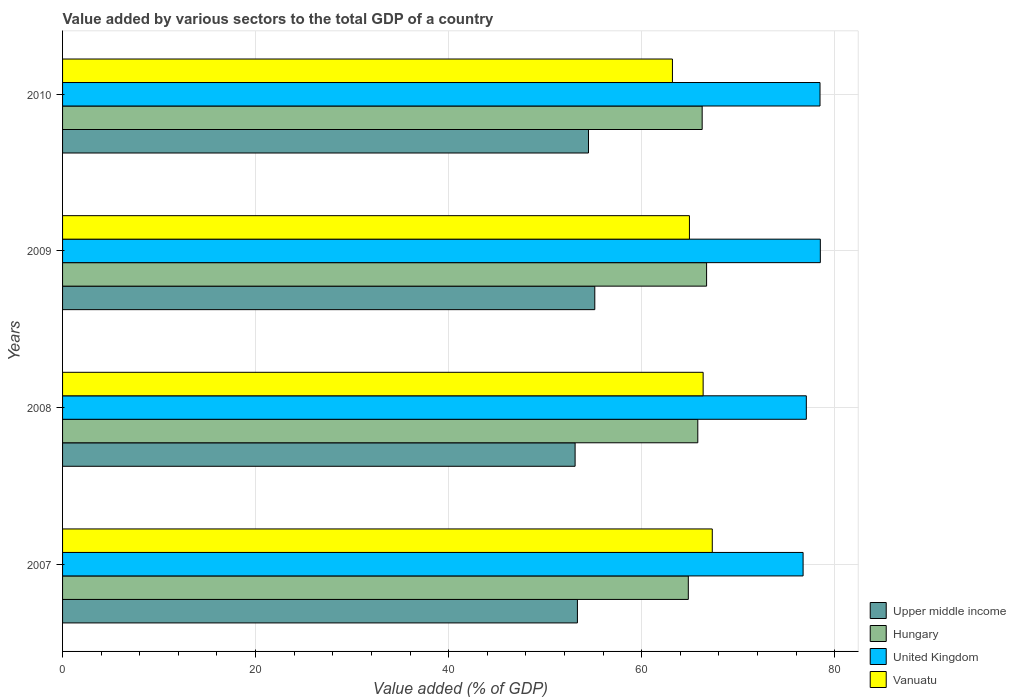How many bars are there on the 2nd tick from the top?
Your answer should be compact. 4. What is the label of the 3rd group of bars from the top?
Your answer should be compact. 2008. What is the value added by various sectors to the total GDP in Hungary in 2009?
Keep it short and to the point. 66.73. Across all years, what is the maximum value added by various sectors to the total GDP in Upper middle income?
Ensure brevity in your answer.  55.15. Across all years, what is the minimum value added by various sectors to the total GDP in United Kingdom?
Your response must be concise. 76.73. In which year was the value added by various sectors to the total GDP in United Kingdom maximum?
Make the answer very short. 2009. In which year was the value added by various sectors to the total GDP in Vanuatu minimum?
Offer a terse response. 2010. What is the total value added by various sectors to the total GDP in United Kingdom in the graph?
Offer a terse response. 310.8. What is the difference between the value added by various sectors to the total GDP in Vanuatu in 2008 and that in 2010?
Provide a succinct answer. 3.18. What is the difference between the value added by various sectors to the total GDP in Vanuatu in 2010 and the value added by various sectors to the total GDP in United Kingdom in 2008?
Your answer should be compact. -13.87. What is the average value added by various sectors to the total GDP in Vanuatu per year?
Offer a terse response. 65.46. In the year 2008, what is the difference between the value added by various sectors to the total GDP in Upper middle income and value added by various sectors to the total GDP in Hungary?
Give a very brief answer. -12.71. In how many years, is the value added by various sectors to the total GDP in Vanuatu greater than 40 %?
Give a very brief answer. 4. What is the ratio of the value added by various sectors to the total GDP in Hungary in 2008 to that in 2009?
Give a very brief answer. 0.99. Is the difference between the value added by various sectors to the total GDP in Upper middle income in 2009 and 2010 greater than the difference between the value added by various sectors to the total GDP in Hungary in 2009 and 2010?
Your response must be concise. Yes. What is the difference between the highest and the second highest value added by various sectors to the total GDP in Hungary?
Provide a short and direct response. 0.46. What is the difference between the highest and the lowest value added by various sectors to the total GDP in Upper middle income?
Make the answer very short. 2.04. What does the 2nd bar from the top in 2007 represents?
Offer a terse response. United Kingdom. What does the 2nd bar from the bottom in 2009 represents?
Offer a terse response. Hungary. How many bars are there?
Provide a succinct answer. 16. Are all the bars in the graph horizontal?
Your response must be concise. Yes. Are the values on the major ticks of X-axis written in scientific E-notation?
Keep it short and to the point. No. Does the graph contain grids?
Your response must be concise. Yes. What is the title of the graph?
Give a very brief answer. Value added by various sectors to the total GDP of a country. Does "Isle of Man" appear as one of the legend labels in the graph?
Give a very brief answer. No. What is the label or title of the X-axis?
Keep it short and to the point. Value added (% of GDP). What is the Value added (% of GDP) of Upper middle income in 2007?
Make the answer very short. 53.35. What is the Value added (% of GDP) in Hungary in 2007?
Ensure brevity in your answer.  64.84. What is the Value added (% of GDP) in United Kingdom in 2007?
Your answer should be very brief. 76.73. What is the Value added (% of GDP) in Vanuatu in 2007?
Give a very brief answer. 67.32. What is the Value added (% of GDP) of Upper middle income in 2008?
Your answer should be very brief. 53.11. What is the Value added (% of GDP) of Hungary in 2008?
Your answer should be very brief. 65.82. What is the Value added (% of GDP) of United Kingdom in 2008?
Your answer should be very brief. 77.07. What is the Value added (% of GDP) of Vanuatu in 2008?
Offer a very short reply. 66.37. What is the Value added (% of GDP) in Upper middle income in 2009?
Your answer should be very brief. 55.15. What is the Value added (% of GDP) in Hungary in 2009?
Offer a terse response. 66.73. What is the Value added (% of GDP) of United Kingdom in 2009?
Give a very brief answer. 78.52. What is the Value added (% of GDP) in Vanuatu in 2009?
Ensure brevity in your answer.  64.95. What is the Value added (% of GDP) in Upper middle income in 2010?
Make the answer very short. 54.49. What is the Value added (% of GDP) of Hungary in 2010?
Your answer should be compact. 66.27. What is the Value added (% of GDP) of United Kingdom in 2010?
Make the answer very short. 78.48. What is the Value added (% of GDP) in Vanuatu in 2010?
Your response must be concise. 63.19. Across all years, what is the maximum Value added (% of GDP) in Upper middle income?
Keep it short and to the point. 55.15. Across all years, what is the maximum Value added (% of GDP) of Hungary?
Offer a terse response. 66.73. Across all years, what is the maximum Value added (% of GDP) of United Kingdom?
Provide a short and direct response. 78.52. Across all years, what is the maximum Value added (% of GDP) in Vanuatu?
Your answer should be very brief. 67.32. Across all years, what is the minimum Value added (% of GDP) of Upper middle income?
Offer a terse response. 53.11. Across all years, what is the minimum Value added (% of GDP) of Hungary?
Your answer should be compact. 64.84. Across all years, what is the minimum Value added (% of GDP) in United Kingdom?
Ensure brevity in your answer.  76.73. Across all years, what is the minimum Value added (% of GDP) of Vanuatu?
Ensure brevity in your answer.  63.19. What is the total Value added (% of GDP) in Upper middle income in the graph?
Offer a terse response. 216.1. What is the total Value added (% of GDP) in Hungary in the graph?
Provide a succinct answer. 263.67. What is the total Value added (% of GDP) in United Kingdom in the graph?
Your answer should be very brief. 310.8. What is the total Value added (% of GDP) in Vanuatu in the graph?
Offer a very short reply. 261.84. What is the difference between the Value added (% of GDP) in Upper middle income in 2007 and that in 2008?
Keep it short and to the point. 0.24. What is the difference between the Value added (% of GDP) of Hungary in 2007 and that in 2008?
Your answer should be very brief. -0.98. What is the difference between the Value added (% of GDP) in United Kingdom in 2007 and that in 2008?
Offer a terse response. -0.33. What is the difference between the Value added (% of GDP) in Vanuatu in 2007 and that in 2008?
Give a very brief answer. 0.95. What is the difference between the Value added (% of GDP) in Upper middle income in 2007 and that in 2009?
Your answer should be very brief. -1.8. What is the difference between the Value added (% of GDP) in Hungary in 2007 and that in 2009?
Provide a succinct answer. -1.89. What is the difference between the Value added (% of GDP) in United Kingdom in 2007 and that in 2009?
Offer a very short reply. -1.78. What is the difference between the Value added (% of GDP) of Vanuatu in 2007 and that in 2009?
Make the answer very short. 2.37. What is the difference between the Value added (% of GDP) of Upper middle income in 2007 and that in 2010?
Provide a succinct answer. -1.15. What is the difference between the Value added (% of GDP) in Hungary in 2007 and that in 2010?
Your answer should be very brief. -1.43. What is the difference between the Value added (% of GDP) in United Kingdom in 2007 and that in 2010?
Your answer should be very brief. -1.75. What is the difference between the Value added (% of GDP) in Vanuatu in 2007 and that in 2010?
Your answer should be very brief. 4.13. What is the difference between the Value added (% of GDP) of Upper middle income in 2008 and that in 2009?
Offer a terse response. -2.04. What is the difference between the Value added (% of GDP) in Hungary in 2008 and that in 2009?
Make the answer very short. -0.91. What is the difference between the Value added (% of GDP) of United Kingdom in 2008 and that in 2009?
Offer a terse response. -1.45. What is the difference between the Value added (% of GDP) in Vanuatu in 2008 and that in 2009?
Make the answer very short. 1.42. What is the difference between the Value added (% of GDP) of Upper middle income in 2008 and that in 2010?
Keep it short and to the point. -1.39. What is the difference between the Value added (% of GDP) of Hungary in 2008 and that in 2010?
Keep it short and to the point. -0.45. What is the difference between the Value added (% of GDP) of United Kingdom in 2008 and that in 2010?
Make the answer very short. -1.42. What is the difference between the Value added (% of GDP) in Vanuatu in 2008 and that in 2010?
Provide a succinct answer. 3.18. What is the difference between the Value added (% of GDP) in Upper middle income in 2009 and that in 2010?
Give a very brief answer. 0.65. What is the difference between the Value added (% of GDP) in Hungary in 2009 and that in 2010?
Provide a short and direct response. 0.46. What is the difference between the Value added (% of GDP) in United Kingdom in 2009 and that in 2010?
Give a very brief answer. 0.03. What is the difference between the Value added (% of GDP) in Vanuatu in 2009 and that in 2010?
Ensure brevity in your answer.  1.76. What is the difference between the Value added (% of GDP) in Upper middle income in 2007 and the Value added (% of GDP) in Hungary in 2008?
Provide a succinct answer. -12.47. What is the difference between the Value added (% of GDP) in Upper middle income in 2007 and the Value added (% of GDP) in United Kingdom in 2008?
Your answer should be very brief. -23.72. What is the difference between the Value added (% of GDP) in Upper middle income in 2007 and the Value added (% of GDP) in Vanuatu in 2008?
Your answer should be very brief. -13.03. What is the difference between the Value added (% of GDP) of Hungary in 2007 and the Value added (% of GDP) of United Kingdom in 2008?
Make the answer very short. -12.23. What is the difference between the Value added (% of GDP) of Hungary in 2007 and the Value added (% of GDP) of Vanuatu in 2008?
Your answer should be compact. -1.54. What is the difference between the Value added (% of GDP) of United Kingdom in 2007 and the Value added (% of GDP) of Vanuatu in 2008?
Keep it short and to the point. 10.36. What is the difference between the Value added (% of GDP) in Upper middle income in 2007 and the Value added (% of GDP) in Hungary in 2009?
Give a very brief answer. -13.38. What is the difference between the Value added (% of GDP) in Upper middle income in 2007 and the Value added (% of GDP) in United Kingdom in 2009?
Provide a succinct answer. -25.17. What is the difference between the Value added (% of GDP) of Upper middle income in 2007 and the Value added (% of GDP) of Vanuatu in 2009?
Give a very brief answer. -11.61. What is the difference between the Value added (% of GDP) in Hungary in 2007 and the Value added (% of GDP) in United Kingdom in 2009?
Give a very brief answer. -13.68. What is the difference between the Value added (% of GDP) of Hungary in 2007 and the Value added (% of GDP) of Vanuatu in 2009?
Provide a succinct answer. -0.12. What is the difference between the Value added (% of GDP) of United Kingdom in 2007 and the Value added (% of GDP) of Vanuatu in 2009?
Your answer should be compact. 11.78. What is the difference between the Value added (% of GDP) of Upper middle income in 2007 and the Value added (% of GDP) of Hungary in 2010?
Provide a short and direct response. -12.93. What is the difference between the Value added (% of GDP) in Upper middle income in 2007 and the Value added (% of GDP) in United Kingdom in 2010?
Make the answer very short. -25.14. What is the difference between the Value added (% of GDP) in Upper middle income in 2007 and the Value added (% of GDP) in Vanuatu in 2010?
Offer a terse response. -9.85. What is the difference between the Value added (% of GDP) of Hungary in 2007 and the Value added (% of GDP) of United Kingdom in 2010?
Offer a terse response. -13.65. What is the difference between the Value added (% of GDP) of Hungary in 2007 and the Value added (% of GDP) of Vanuatu in 2010?
Ensure brevity in your answer.  1.65. What is the difference between the Value added (% of GDP) of United Kingdom in 2007 and the Value added (% of GDP) of Vanuatu in 2010?
Your answer should be compact. 13.54. What is the difference between the Value added (% of GDP) in Upper middle income in 2008 and the Value added (% of GDP) in Hungary in 2009?
Offer a terse response. -13.62. What is the difference between the Value added (% of GDP) in Upper middle income in 2008 and the Value added (% of GDP) in United Kingdom in 2009?
Your answer should be compact. -25.41. What is the difference between the Value added (% of GDP) of Upper middle income in 2008 and the Value added (% of GDP) of Vanuatu in 2009?
Keep it short and to the point. -11.85. What is the difference between the Value added (% of GDP) of Hungary in 2008 and the Value added (% of GDP) of United Kingdom in 2009?
Offer a terse response. -12.7. What is the difference between the Value added (% of GDP) in Hungary in 2008 and the Value added (% of GDP) in Vanuatu in 2009?
Make the answer very short. 0.87. What is the difference between the Value added (% of GDP) of United Kingdom in 2008 and the Value added (% of GDP) of Vanuatu in 2009?
Make the answer very short. 12.11. What is the difference between the Value added (% of GDP) of Upper middle income in 2008 and the Value added (% of GDP) of Hungary in 2010?
Your answer should be very brief. -13.17. What is the difference between the Value added (% of GDP) in Upper middle income in 2008 and the Value added (% of GDP) in United Kingdom in 2010?
Your response must be concise. -25.38. What is the difference between the Value added (% of GDP) in Upper middle income in 2008 and the Value added (% of GDP) in Vanuatu in 2010?
Give a very brief answer. -10.09. What is the difference between the Value added (% of GDP) in Hungary in 2008 and the Value added (% of GDP) in United Kingdom in 2010?
Offer a terse response. -12.66. What is the difference between the Value added (% of GDP) of Hungary in 2008 and the Value added (% of GDP) of Vanuatu in 2010?
Give a very brief answer. 2.63. What is the difference between the Value added (% of GDP) of United Kingdom in 2008 and the Value added (% of GDP) of Vanuatu in 2010?
Ensure brevity in your answer.  13.87. What is the difference between the Value added (% of GDP) of Upper middle income in 2009 and the Value added (% of GDP) of Hungary in 2010?
Give a very brief answer. -11.13. What is the difference between the Value added (% of GDP) in Upper middle income in 2009 and the Value added (% of GDP) in United Kingdom in 2010?
Your answer should be compact. -23.34. What is the difference between the Value added (% of GDP) of Upper middle income in 2009 and the Value added (% of GDP) of Vanuatu in 2010?
Give a very brief answer. -8.04. What is the difference between the Value added (% of GDP) in Hungary in 2009 and the Value added (% of GDP) in United Kingdom in 2010?
Your response must be concise. -11.75. What is the difference between the Value added (% of GDP) of Hungary in 2009 and the Value added (% of GDP) of Vanuatu in 2010?
Make the answer very short. 3.54. What is the difference between the Value added (% of GDP) in United Kingdom in 2009 and the Value added (% of GDP) in Vanuatu in 2010?
Your answer should be very brief. 15.32. What is the average Value added (% of GDP) of Upper middle income per year?
Give a very brief answer. 54.02. What is the average Value added (% of GDP) of Hungary per year?
Your answer should be compact. 65.92. What is the average Value added (% of GDP) of United Kingdom per year?
Ensure brevity in your answer.  77.7. What is the average Value added (% of GDP) of Vanuatu per year?
Your response must be concise. 65.46. In the year 2007, what is the difference between the Value added (% of GDP) of Upper middle income and Value added (% of GDP) of Hungary?
Offer a terse response. -11.49. In the year 2007, what is the difference between the Value added (% of GDP) of Upper middle income and Value added (% of GDP) of United Kingdom?
Your answer should be compact. -23.38. In the year 2007, what is the difference between the Value added (% of GDP) in Upper middle income and Value added (% of GDP) in Vanuatu?
Your answer should be very brief. -13.97. In the year 2007, what is the difference between the Value added (% of GDP) of Hungary and Value added (% of GDP) of United Kingdom?
Your answer should be very brief. -11.89. In the year 2007, what is the difference between the Value added (% of GDP) in Hungary and Value added (% of GDP) in Vanuatu?
Your response must be concise. -2.48. In the year 2007, what is the difference between the Value added (% of GDP) of United Kingdom and Value added (% of GDP) of Vanuatu?
Offer a very short reply. 9.41. In the year 2008, what is the difference between the Value added (% of GDP) in Upper middle income and Value added (% of GDP) in Hungary?
Make the answer very short. -12.71. In the year 2008, what is the difference between the Value added (% of GDP) of Upper middle income and Value added (% of GDP) of United Kingdom?
Provide a short and direct response. -23.96. In the year 2008, what is the difference between the Value added (% of GDP) in Upper middle income and Value added (% of GDP) in Vanuatu?
Offer a terse response. -13.27. In the year 2008, what is the difference between the Value added (% of GDP) in Hungary and Value added (% of GDP) in United Kingdom?
Your answer should be compact. -11.24. In the year 2008, what is the difference between the Value added (% of GDP) in Hungary and Value added (% of GDP) in Vanuatu?
Offer a terse response. -0.55. In the year 2008, what is the difference between the Value added (% of GDP) of United Kingdom and Value added (% of GDP) of Vanuatu?
Your response must be concise. 10.69. In the year 2009, what is the difference between the Value added (% of GDP) in Upper middle income and Value added (% of GDP) in Hungary?
Provide a succinct answer. -11.58. In the year 2009, what is the difference between the Value added (% of GDP) in Upper middle income and Value added (% of GDP) in United Kingdom?
Your answer should be compact. -23.37. In the year 2009, what is the difference between the Value added (% of GDP) of Upper middle income and Value added (% of GDP) of Vanuatu?
Your answer should be very brief. -9.81. In the year 2009, what is the difference between the Value added (% of GDP) of Hungary and Value added (% of GDP) of United Kingdom?
Offer a terse response. -11.78. In the year 2009, what is the difference between the Value added (% of GDP) of Hungary and Value added (% of GDP) of Vanuatu?
Keep it short and to the point. 1.78. In the year 2009, what is the difference between the Value added (% of GDP) in United Kingdom and Value added (% of GDP) in Vanuatu?
Your response must be concise. 13.56. In the year 2010, what is the difference between the Value added (% of GDP) in Upper middle income and Value added (% of GDP) in Hungary?
Provide a short and direct response. -11.78. In the year 2010, what is the difference between the Value added (% of GDP) in Upper middle income and Value added (% of GDP) in United Kingdom?
Provide a short and direct response. -23.99. In the year 2010, what is the difference between the Value added (% of GDP) of Upper middle income and Value added (% of GDP) of Vanuatu?
Your response must be concise. -8.7. In the year 2010, what is the difference between the Value added (% of GDP) in Hungary and Value added (% of GDP) in United Kingdom?
Provide a short and direct response. -12.21. In the year 2010, what is the difference between the Value added (% of GDP) in Hungary and Value added (% of GDP) in Vanuatu?
Offer a very short reply. 3.08. In the year 2010, what is the difference between the Value added (% of GDP) of United Kingdom and Value added (% of GDP) of Vanuatu?
Your answer should be compact. 15.29. What is the ratio of the Value added (% of GDP) of Upper middle income in 2007 to that in 2008?
Your answer should be very brief. 1. What is the ratio of the Value added (% of GDP) in Hungary in 2007 to that in 2008?
Offer a terse response. 0.99. What is the ratio of the Value added (% of GDP) in United Kingdom in 2007 to that in 2008?
Provide a short and direct response. 1. What is the ratio of the Value added (% of GDP) in Vanuatu in 2007 to that in 2008?
Your answer should be very brief. 1.01. What is the ratio of the Value added (% of GDP) in Upper middle income in 2007 to that in 2009?
Offer a very short reply. 0.97. What is the ratio of the Value added (% of GDP) of Hungary in 2007 to that in 2009?
Provide a short and direct response. 0.97. What is the ratio of the Value added (% of GDP) of United Kingdom in 2007 to that in 2009?
Your answer should be compact. 0.98. What is the ratio of the Value added (% of GDP) in Vanuatu in 2007 to that in 2009?
Keep it short and to the point. 1.04. What is the ratio of the Value added (% of GDP) of Hungary in 2007 to that in 2010?
Provide a succinct answer. 0.98. What is the ratio of the Value added (% of GDP) of United Kingdom in 2007 to that in 2010?
Your answer should be very brief. 0.98. What is the ratio of the Value added (% of GDP) in Vanuatu in 2007 to that in 2010?
Your answer should be compact. 1.07. What is the ratio of the Value added (% of GDP) of Upper middle income in 2008 to that in 2009?
Provide a succinct answer. 0.96. What is the ratio of the Value added (% of GDP) in Hungary in 2008 to that in 2009?
Your response must be concise. 0.99. What is the ratio of the Value added (% of GDP) of United Kingdom in 2008 to that in 2009?
Give a very brief answer. 0.98. What is the ratio of the Value added (% of GDP) of Vanuatu in 2008 to that in 2009?
Offer a very short reply. 1.02. What is the ratio of the Value added (% of GDP) of Upper middle income in 2008 to that in 2010?
Provide a succinct answer. 0.97. What is the ratio of the Value added (% of GDP) in Hungary in 2008 to that in 2010?
Your answer should be compact. 0.99. What is the ratio of the Value added (% of GDP) in United Kingdom in 2008 to that in 2010?
Keep it short and to the point. 0.98. What is the ratio of the Value added (% of GDP) in Vanuatu in 2008 to that in 2010?
Your response must be concise. 1.05. What is the ratio of the Value added (% of GDP) of Upper middle income in 2009 to that in 2010?
Offer a very short reply. 1.01. What is the ratio of the Value added (% of GDP) in Vanuatu in 2009 to that in 2010?
Offer a terse response. 1.03. What is the difference between the highest and the second highest Value added (% of GDP) of Upper middle income?
Offer a very short reply. 0.65. What is the difference between the highest and the second highest Value added (% of GDP) of Hungary?
Give a very brief answer. 0.46. What is the difference between the highest and the second highest Value added (% of GDP) in United Kingdom?
Provide a succinct answer. 0.03. What is the difference between the highest and the second highest Value added (% of GDP) in Vanuatu?
Your response must be concise. 0.95. What is the difference between the highest and the lowest Value added (% of GDP) in Upper middle income?
Your answer should be compact. 2.04. What is the difference between the highest and the lowest Value added (% of GDP) of Hungary?
Offer a terse response. 1.89. What is the difference between the highest and the lowest Value added (% of GDP) of United Kingdom?
Your response must be concise. 1.78. What is the difference between the highest and the lowest Value added (% of GDP) of Vanuatu?
Offer a terse response. 4.13. 